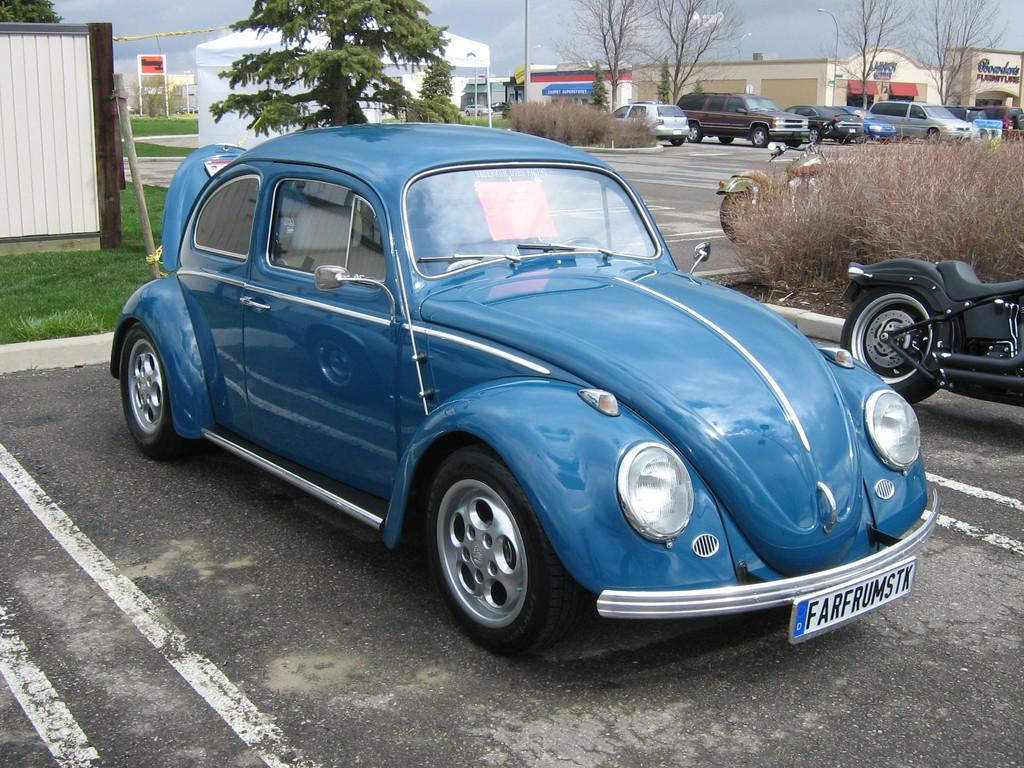What can be seen on the road in the image? There are vehicles on the road in the image. What type of structures are visible in the image? There are buildings in the image. What objects are present in the image that might be used for displaying information or advertisements? There are boards in the image. What type of vertical structures can be seen in the image that provide illumination? There are light poles in the image. What type of natural elements are present in the image? There are trees and plants in the image. What type of temporary shelter is visible in the image? There is a tent in the image. What is visible at the top of the image? The sky is visible at the top of the image. How does the tent express regret in the image? The tent does not express regret in the image; it is a temporary shelter with no emotions or expressions. What type of knot is used to secure the vehicles to the light poles in the image? There are no knots used to secure vehicles to light poles in the image; the vehicles are on the road and not attached to any poles. 